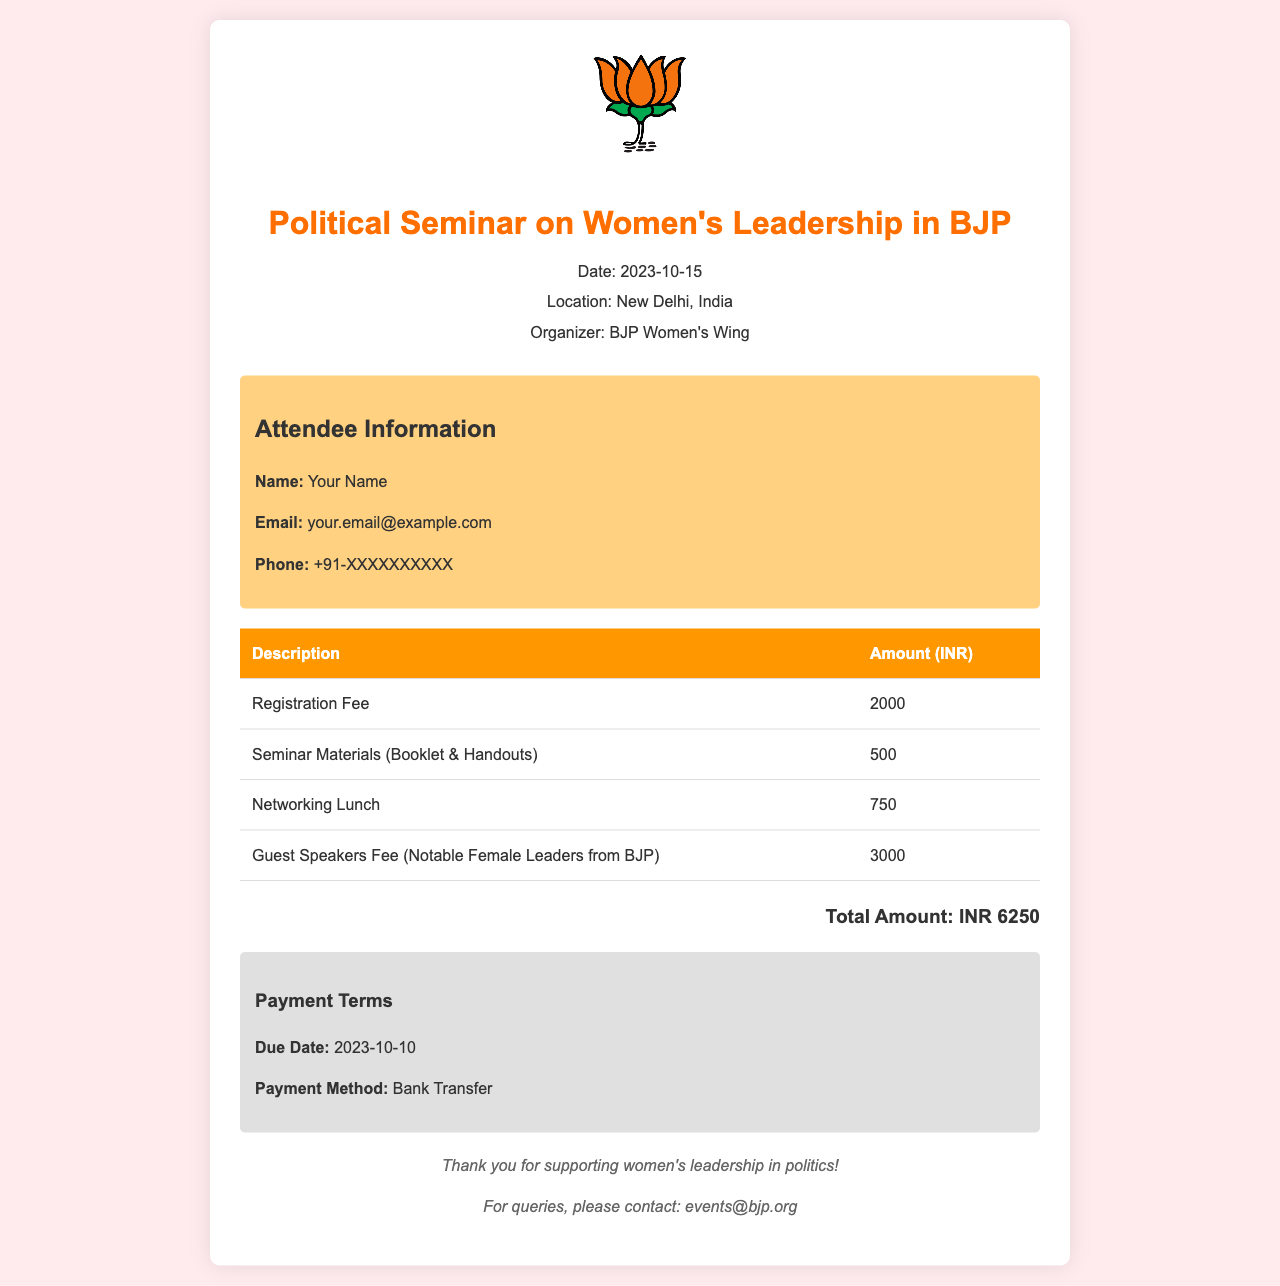What is the date of the seminar? The date of the seminar is specified in the document header.
Answer: 2023-10-15 What is the total amount due? The total amount is calculated at the bottom of the items table in the document.
Answer: INR 6250 Who organized the seminar? The organizer is mentioned in the header section of the invoice.
Answer: BJP Women's Wing What is the registration fee? The registration fee is detailed in the items table of the document.
Answer: 2000 What payment method is accepted? The payment method is listed under the payment terms section in the document.
Answer: Bank Transfer How much is the fee for guest speakers? The fee for guest speakers is included in the items table.
Answer: 3000 What will attendees receive as seminar materials? The seminar materials are defined in the items table.
Answer: Booklet & Handouts What is the due date for payment? The due date is specified in the payment terms section of the document.
Answer: 2023-10-10 